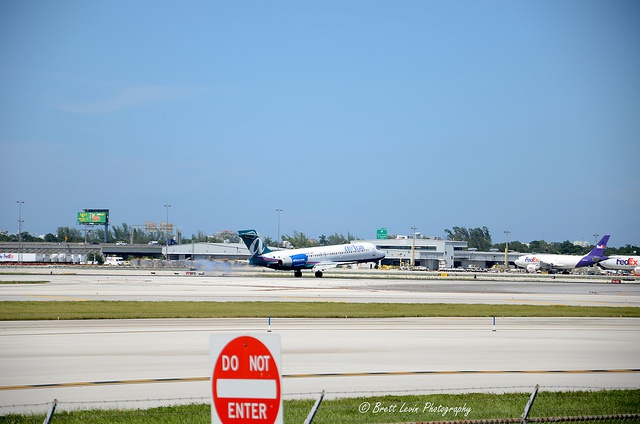Describe the objects in this image and their specific colors. I can see airplane in gray, white, black, and darkgray tones, airplane in gray, white, darkgray, and blue tones, truck in gray, lightgray, and darkgray tones, truck in gray, white, darkgray, and lightpink tones, and truck in gray, darkgray, lightgray, and black tones in this image. 